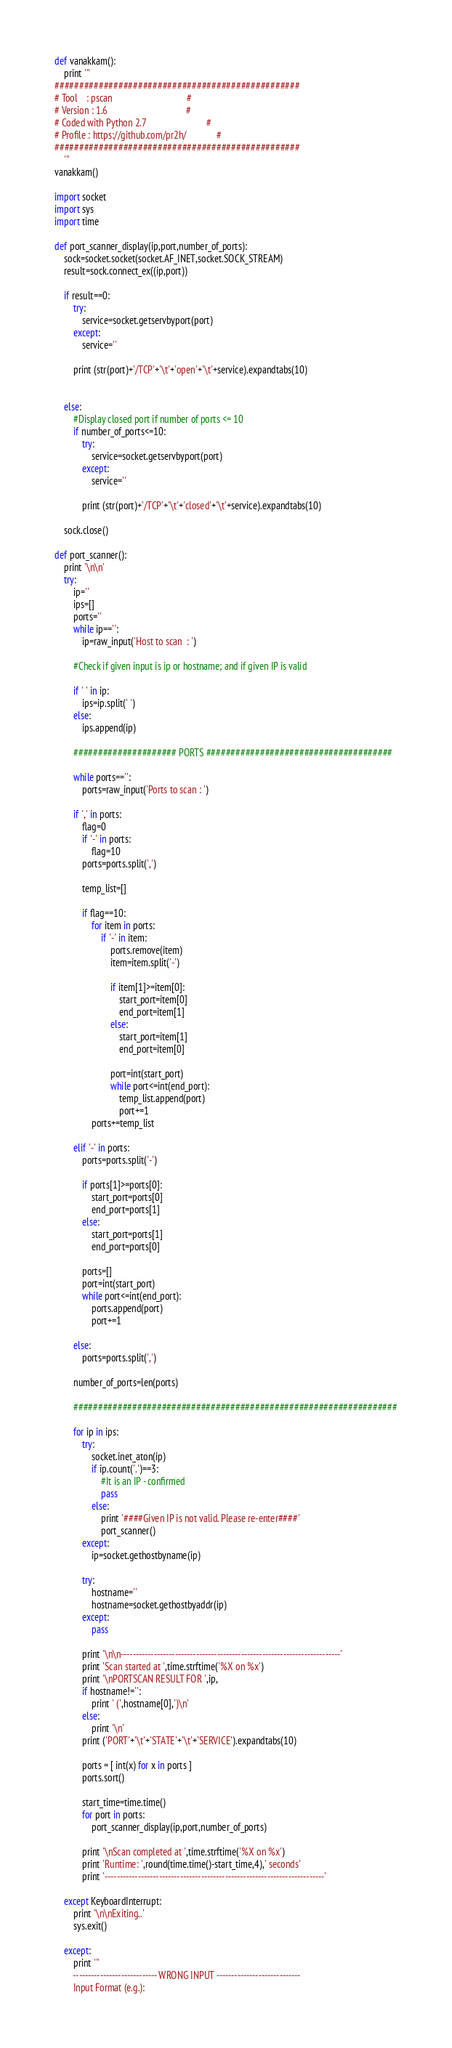<code> <loc_0><loc_0><loc_500><loc_500><_Python_>def vanakkam():
    print '''
##################################################
# Tool    : pscan                                #
# Version : 1.6                                  #
# Coded with Python 2.7                          #
# Profile : https://github.com/pr2h/             #
##################################################
    '''
vanakkam()

import socket
import sys
import time

def port_scanner_display(ip,port,number_of_ports):
    sock=socket.socket(socket.AF_INET,socket.SOCK_STREAM)
    result=sock.connect_ex((ip,port))

    if result==0:
        try:
            service=socket.getservbyport(port)
        except:
            service=''
            
        print (str(port)+'/TCP'+'\t'+'open'+'\t'+service).expandtabs(10)
        
        
    else:
        #Display closed port if number of ports <= 10
        if number_of_ports<=10:
            try:
                service=socket.getservbyport(port)
            except:
                service=''
            
            print (str(port)+'/TCP'+'\t'+'closed'+'\t'+service).expandtabs(10)

    sock.close()

def port_scanner():
    print '\n\n'
    try:
        ip=''
        ips=[]
        ports=''
        while ip=='':
            ip=raw_input('Host to scan  : ')

        #Check if given input is ip or hostname; and if given IP is valid
    
        if ' ' in ip:
            ips=ip.split(' ')
        else:
            ips.append(ip)

        ##################### PORTS ######################################

        while ports=='':
            ports=raw_input('Ports to scan : ')

        if ',' in ports:
            flag=0
            if '-' in ports:
                flag=10
            ports=ports.split(',')

            temp_list=[]
                
            if flag==10:
                for item in ports:
                    if '-' in item:
                        ports.remove(item)
                        item=item.split('-')

                        if item[1]>=item[0]:
                            start_port=item[0]
                            end_port=item[1]
                        else:
                            start_port=item[1]
                            end_port=item[0]
                            
                        port=int(start_port)
                        while port<=int(end_port):
                            temp_list.append(port)
                            port+=1
                ports+=temp_list

        elif '-' in ports:
            ports=ports.split('-')

            if ports[1]>=ports[0]:
                start_port=ports[0]
                end_port=ports[1]
            else:
                start_port=ports[1]
                end_port=ports[0]

            ports=[]
            port=int(start_port)
            while port<=int(end_port):
                ports.append(port)
                port+=1

        else:
            ports=ports.split(',')

        number_of_ports=len(ports)

        ##################################################################
        
        for ip in ips:
            try:
                socket.inet_aton(ip)
                if ip.count('.')==3:
                    #It is an IP - confirmed
                    pass
                else:
                    print '####Given IP is not valid. Please re-enter####'
                    port_scanner()
            except:
                ip=socket.gethostbyname(ip)

            try:
                hostname=''
                hostname=socket.gethostbyaddr(ip)
            except:
                pass
            
            print '\n\n-------------------------------------------------------------------------'
            print 'Scan started at ',time.strftime('%X on %x')
            print '\nPORTSCAN RESULT FOR ',ip,
            if hostname!='':
                print ' (',hostname[0],')\n'
            else:
                print '\n'
            print ('PORT'+'\t'+'STATE'+'\t'+'SERVICE').expandtabs(10)
                    
            ports = [ int(x) for x in ports ]
            ports.sort()

            start_time=time.time()
            for port in ports:
                port_scanner_display(ip,port,number_of_ports)

            print '\nScan completed at ',time.strftime('%X on %x')
            print 'Runtime: ',round(time.time()-start_time,4),' seconds'
            print '-------------------------------------------------------------------------'

    except KeyboardInterrupt:
        print '\n\nExiting..'
        sys.exit()

    except:
        print '''
        ---------------------------- WRONG INPUT ----------------------------
        Input Format (e.g.):
</code> 